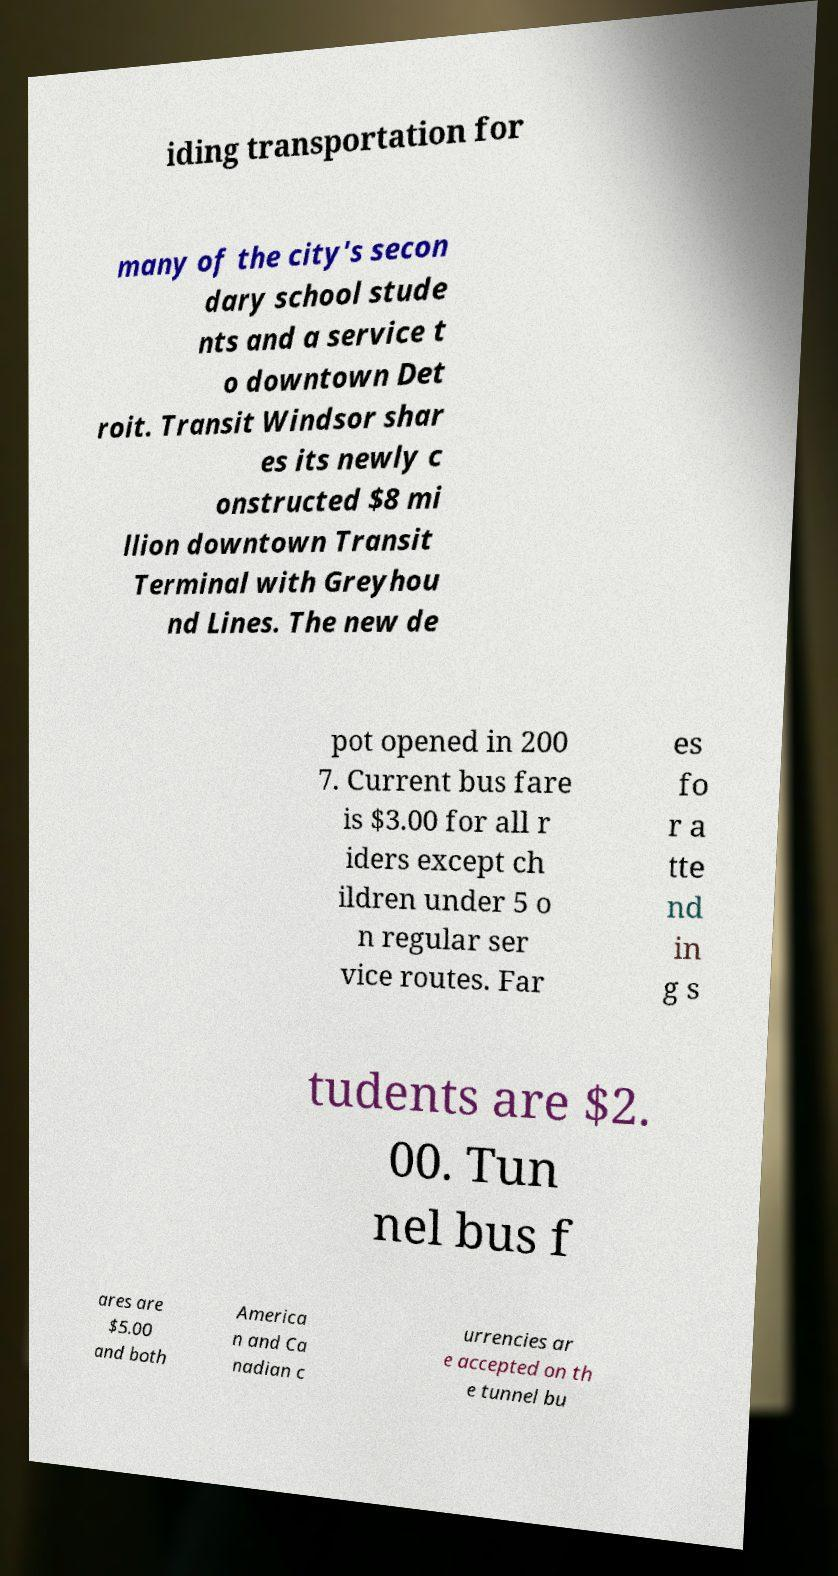Can you accurately transcribe the text from the provided image for me? iding transportation for many of the city's secon dary school stude nts and a service t o downtown Det roit. Transit Windsor shar es its newly c onstructed $8 mi llion downtown Transit Terminal with Greyhou nd Lines. The new de pot opened in 200 7. Current bus fare is $3.00 for all r iders except ch ildren under 5 o n regular ser vice routes. Far es fo r a tte nd in g s tudents are $2. 00. Tun nel bus f ares are $5.00 and both America n and Ca nadian c urrencies ar e accepted on th e tunnel bu 